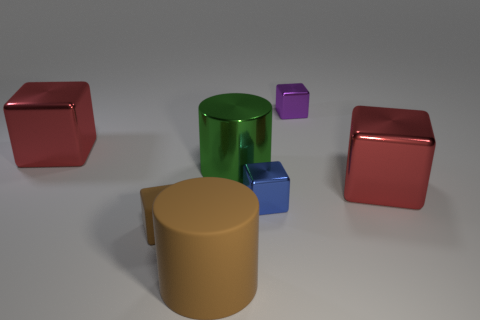Is the number of tiny purple metal objects in front of the green metallic thing less than the number of purple metallic objects left of the big rubber cylinder?
Keep it short and to the point. No. What shape is the small metal object that is in front of the large shiny cube that is right of the tiny blue block to the right of the brown block?
Keep it short and to the point. Cube. There is a big thing that is both on the left side of the big shiny cylinder and right of the tiny brown rubber thing; what is its shape?
Provide a succinct answer. Cylinder. Is there a small block made of the same material as the tiny purple object?
Give a very brief answer. Yes. What size is the other thing that is the same color as the tiny rubber thing?
Keep it short and to the point. Large. There is a tiny metal cube in front of the big green metal thing; what color is it?
Your answer should be compact. Blue. Does the purple object have the same shape as the big thing on the right side of the blue metallic thing?
Ensure brevity in your answer.  Yes. Are there any tiny shiny cubes that have the same color as the shiny cylinder?
Your response must be concise. No. There is a brown cube that is the same material as the brown cylinder; what is its size?
Provide a succinct answer. Small. Do the matte cube and the big matte cylinder have the same color?
Your answer should be compact. Yes. 